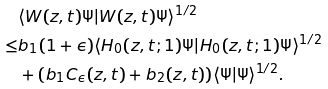<formula> <loc_0><loc_0><loc_500><loc_500>& \langle W ( z , t ) \Psi | W ( z , t ) \Psi \rangle ^ { 1 / 2 } \\ \leq & b _ { 1 } ( 1 + \epsilon ) \langle H _ { 0 } ( z , t ; 1 ) \Psi | H _ { 0 } ( z , t ; 1 ) \Psi \rangle ^ { 1 / 2 } \\ & + ( b _ { 1 } C _ { \epsilon } ( z , t ) + b _ { 2 } ( z , t ) ) \langle \Psi | \Psi \rangle ^ { 1 / 2 } .</formula> 